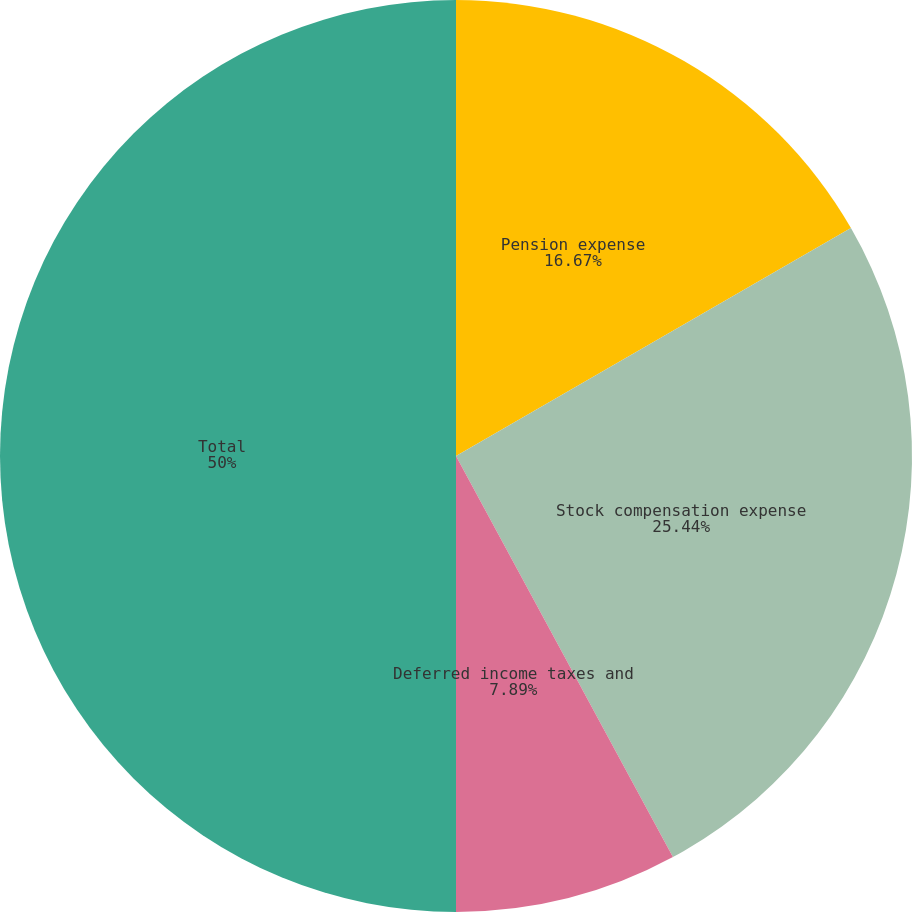<chart> <loc_0><loc_0><loc_500><loc_500><pie_chart><fcel>Pension expense<fcel>Stock compensation expense<fcel>Deferred income taxes and<fcel>Total<nl><fcel>16.67%<fcel>25.44%<fcel>7.89%<fcel>50.0%<nl></chart> 